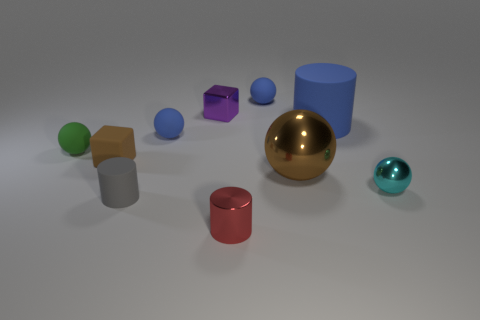Is the size of the gray rubber cylinder the same as the brown object that is on the right side of the tiny purple metal cube?
Keep it short and to the point. No. What number of purple objects are metal objects or large matte cylinders?
Keep it short and to the point. 1. How many big gray cylinders are there?
Give a very brief answer. 0. What size is the brown thing right of the tiny purple cube?
Ensure brevity in your answer.  Large. Is the blue rubber cylinder the same size as the red shiny object?
Provide a short and direct response. No. How many objects are either purple cubes or shiny spheres that are behind the tiny cyan object?
Provide a short and direct response. 2. What is the small purple block made of?
Offer a terse response. Metal. Is there any other thing of the same color as the metal cylinder?
Keep it short and to the point. No. Do the brown rubber object and the purple metal object have the same shape?
Make the answer very short. Yes. There is a cylinder that is behind the small cylinder that is to the left of the tiny blue object that is in front of the small purple cube; what size is it?
Keep it short and to the point. Large. 